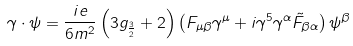Convert formula to latex. <formula><loc_0><loc_0><loc_500><loc_500>\gamma \cdot \psi = \frac { i e } { 6 m ^ { 2 } } \left ( 3 g _ { \frac { 3 } { 2 } } + 2 \right ) \left ( F _ { \mu \beta } \gamma ^ { \mu } + i \gamma ^ { 5 } \gamma ^ { \alpha } \tilde { F } _ { \beta \alpha } \right ) \psi ^ { \beta }</formula> 